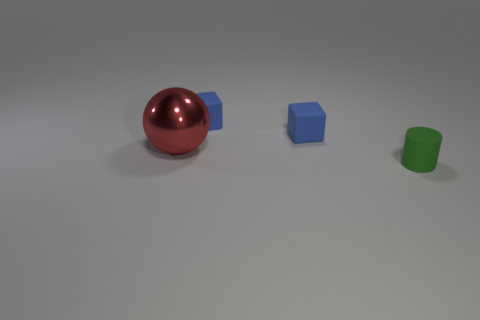Is there anything else that is the same size as the red thing?
Provide a succinct answer. No. There is a object that is in front of the red metal ball; is it the same color as the large sphere?
Provide a short and direct response. No. What number of blocks are either red metal things or green rubber objects?
Keep it short and to the point. 0. The large metal object has what shape?
Provide a short and direct response. Sphere. Are the thing in front of the red thing and the large red thing made of the same material?
Your answer should be compact. No. What number of other things are there of the same material as the small green object
Provide a short and direct response. 2. What number of other objects are there of the same color as the shiny thing?
Your response must be concise. 0. There is a object in front of the big red object; what is its size?
Provide a short and direct response. Small. The small object in front of the red sphere has what shape?
Provide a short and direct response. Cylinder. How many small blue matte things are the same shape as the green rubber object?
Ensure brevity in your answer.  0. 